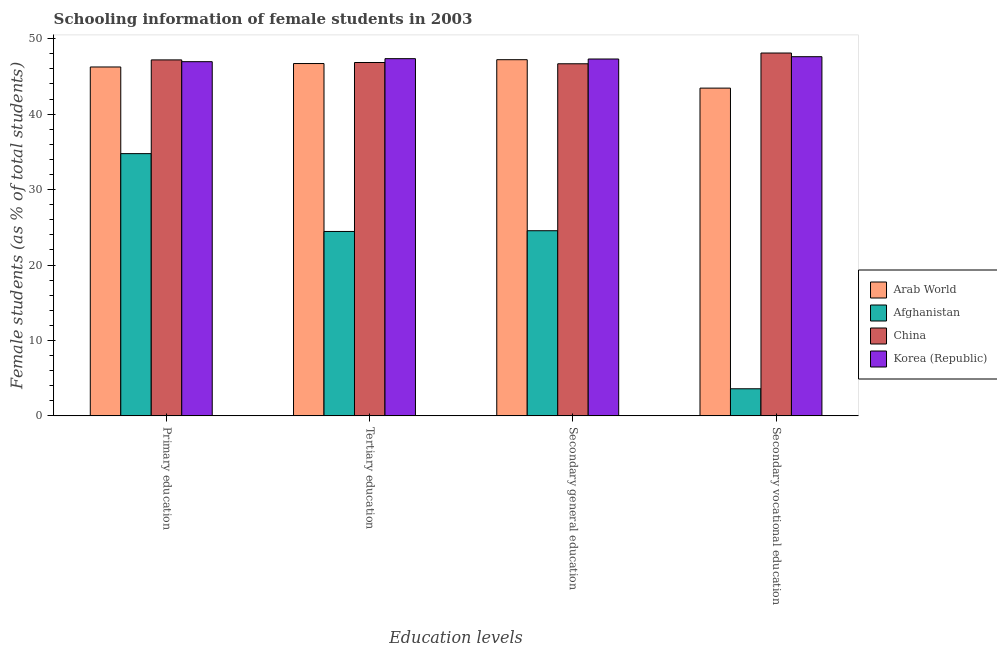Are the number of bars per tick equal to the number of legend labels?
Keep it short and to the point. Yes. Are the number of bars on each tick of the X-axis equal?
Your response must be concise. Yes. What is the label of the 3rd group of bars from the left?
Provide a succinct answer. Secondary general education. What is the percentage of female students in primary education in Afghanistan?
Provide a succinct answer. 34.76. Across all countries, what is the maximum percentage of female students in primary education?
Provide a succinct answer. 47.19. Across all countries, what is the minimum percentage of female students in secondary education?
Provide a short and direct response. 24.54. In which country was the percentage of female students in secondary vocational education maximum?
Your answer should be compact. China. In which country was the percentage of female students in primary education minimum?
Offer a terse response. Afghanistan. What is the total percentage of female students in secondary education in the graph?
Give a very brief answer. 165.75. What is the difference between the percentage of female students in secondary vocational education in Arab World and that in Afghanistan?
Provide a succinct answer. 39.86. What is the difference between the percentage of female students in secondary education in Afghanistan and the percentage of female students in secondary vocational education in China?
Make the answer very short. -23.56. What is the average percentage of female students in primary education per country?
Keep it short and to the point. 43.79. What is the difference between the percentage of female students in secondary vocational education and percentage of female students in secondary education in Arab World?
Provide a succinct answer. -3.77. In how many countries, is the percentage of female students in secondary education greater than 44 %?
Give a very brief answer. 3. What is the ratio of the percentage of female students in tertiary education in Afghanistan to that in Arab World?
Provide a succinct answer. 0.52. What is the difference between the highest and the second highest percentage of female students in secondary education?
Provide a succinct answer. 0.09. What is the difference between the highest and the lowest percentage of female students in tertiary education?
Provide a short and direct response. 22.91. In how many countries, is the percentage of female students in primary education greater than the average percentage of female students in primary education taken over all countries?
Your answer should be very brief. 3. Is the sum of the percentage of female students in tertiary education in China and Korea (Republic) greater than the maximum percentage of female students in primary education across all countries?
Ensure brevity in your answer.  Yes. Is it the case that in every country, the sum of the percentage of female students in secondary vocational education and percentage of female students in tertiary education is greater than the sum of percentage of female students in secondary education and percentage of female students in primary education?
Keep it short and to the point. No. What does the 2nd bar from the left in Secondary general education represents?
Give a very brief answer. Afghanistan. What does the 3rd bar from the right in Secondary general education represents?
Provide a short and direct response. Afghanistan. How many countries are there in the graph?
Offer a very short reply. 4. Are the values on the major ticks of Y-axis written in scientific E-notation?
Offer a terse response. No. Where does the legend appear in the graph?
Your answer should be compact. Center right. How many legend labels are there?
Give a very brief answer. 4. How are the legend labels stacked?
Your answer should be compact. Vertical. What is the title of the graph?
Provide a succinct answer. Schooling information of female students in 2003. Does "Solomon Islands" appear as one of the legend labels in the graph?
Offer a terse response. No. What is the label or title of the X-axis?
Ensure brevity in your answer.  Education levels. What is the label or title of the Y-axis?
Provide a succinct answer. Female students (as % of total students). What is the Female students (as % of total students) in Arab World in Primary education?
Provide a succinct answer. 46.25. What is the Female students (as % of total students) in Afghanistan in Primary education?
Ensure brevity in your answer.  34.76. What is the Female students (as % of total students) of China in Primary education?
Your answer should be very brief. 47.19. What is the Female students (as % of total students) in Korea (Republic) in Primary education?
Your answer should be compact. 46.95. What is the Female students (as % of total students) of Arab World in Tertiary education?
Your answer should be very brief. 46.71. What is the Female students (as % of total students) in Afghanistan in Tertiary education?
Your answer should be very brief. 24.45. What is the Female students (as % of total students) of China in Tertiary education?
Your answer should be compact. 46.85. What is the Female students (as % of total students) in Korea (Republic) in Tertiary education?
Your answer should be compact. 47.35. What is the Female students (as % of total students) of Arab World in Secondary general education?
Keep it short and to the point. 47.22. What is the Female students (as % of total students) of Afghanistan in Secondary general education?
Offer a terse response. 24.54. What is the Female students (as % of total students) in China in Secondary general education?
Offer a terse response. 46.68. What is the Female students (as % of total students) in Korea (Republic) in Secondary general education?
Offer a very short reply. 47.31. What is the Female students (as % of total students) in Arab World in Secondary vocational education?
Give a very brief answer. 43.45. What is the Female students (as % of total students) in Afghanistan in Secondary vocational education?
Offer a terse response. 3.59. What is the Female students (as % of total students) of China in Secondary vocational education?
Your answer should be very brief. 48.1. What is the Female students (as % of total students) in Korea (Republic) in Secondary vocational education?
Make the answer very short. 47.62. Across all Education levels, what is the maximum Female students (as % of total students) in Arab World?
Provide a short and direct response. 47.22. Across all Education levels, what is the maximum Female students (as % of total students) in Afghanistan?
Your answer should be compact. 34.76. Across all Education levels, what is the maximum Female students (as % of total students) of China?
Your response must be concise. 48.1. Across all Education levels, what is the maximum Female students (as % of total students) in Korea (Republic)?
Ensure brevity in your answer.  47.62. Across all Education levels, what is the minimum Female students (as % of total students) of Arab World?
Provide a short and direct response. 43.45. Across all Education levels, what is the minimum Female students (as % of total students) in Afghanistan?
Provide a short and direct response. 3.59. Across all Education levels, what is the minimum Female students (as % of total students) of China?
Provide a succinct answer. 46.68. Across all Education levels, what is the minimum Female students (as % of total students) in Korea (Republic)?
Offer a terse response. 46.95. What is the total Female students (as % of total students) in Arab World in the graph?
Offer a terse response. 183.63. What is the total Female students (as % of total students) of Afghanistan in the graph?
Keep it short and to the point. 87.35. What is the total Female students (as % of total students) in China in the graph?
Give a very brief answer. 188.82. What is the total Female students (as % of total students) in Korea (Republic) in the graph?
Keep it short and to the point. 189.23. What is the difference between the Female students (as % of total students) in Arab World in Primary education and that in Tertiary education?
Provide a succinct answer. -0.46. What is the difference between the Female students (as % of total students) of Afghanistan in Primary education and that in Tertiary education?
Offer a very short reply. 10.32. What is the difference between the Female students (as % of total students) in China in Primary education and that in Tertiary education?
Ensure brevity in your answer.  0.35. What is the difference between the Female students (as % of total students) in Korea (Republic) in Primary education and that in Tertiary education?
Make the answer very short. -0.4. What is the difference between the Female students (as % of total students) of Arab World in Primary education and that in Secondary general education?
Your answer should be compact. -0.96. What is the difference between the Female students (as % of total students) of Afghanistan in Primary education and that in Secondary general education?
Keep it short and to the point. 10.22. What is the difference between the Female students (as % of total students) of China in Primary education and that in Secondary general education?
Offer a terse response. 0.51. What is the difference between the Female students (as % of total students) in Korea (Republic) in Primary education and that in Secondary general education?
Give a very brief answer. -0.35. What is the difference between the Female students (as % of total students) in Arab World in Primary education and that in Secondary vocational education?
Provide a succinct answer. 2.8. What is the difference between the Female students (as % of total students) of Afghanistan in Primary education and that in Secondary vocational education?
Provide a succinct answer. 31.17. What is the difference between the Female students (as % of total students) of China in Primary education and that in Secondary vocational education?
Ensure brevity in your answer.  -0.91. What is the difference between the Female students (as % of total students) of Korea (Republic) in Primary education and that in Secondary vocational education?
Ensure brevity in your answer.  -0.66. What is the difference between the Female students (as % of total students) of Arab World in Tertiary education and that in Secondary general education?
Your answer should be very brief. -0.51. What is the difference between the Female students (as % of total students) in Afghanistan in Tertiary education and that in Secondary general education?
Your answer should be compact. -0.1. What is the difference between the Female students (as % of total students) of China in Tertiary education and that in Secondary general education?
Make the answer very short. 0.17. What is the difference between the Female students (as % of total students) in Korea (Republic) in Tertiary education and that in Secondary general education?
Your answer should be very brief. 0.05. What is the difference between the Female students (as % of total students) in Arab World in Tertiary education and that in Secondary vocational education?
Make the answer very short. 3.26. What is the difference between the Female students (as % of total students) in Afghanistan in Tertiary education and that in Secondary vocational education?
Your answer should be very brief. 20.85. What is the difference between the Female students (as % of total students) in China in Tertiary education and that in Secondary vocational education?
Your answer should be very brief. -1.26. What is the difference between the Female students (as % of total students) in Korea (Republic) in Tertiary education and that in Secondary vocational education?
Your answer should be very brief. -0.26. What is the difference between the Female students (as % of total students) of Arab World in Secondary general education and that in Secondary vocational education?
Your answer should be very brief. 3.77. What is the difference between the Female students (as % of total students) in Afghanistan in Secondary general education and that in Secondary vocational education?
Provide a short and direct response. 20.95. What is the difference between the Female students (as % of total students) in China in Secondary general education and that in Secondary vocational education?
Offer a terse response. -1.43. What is the difference between the Female students (as % of total students) of Korea (Republic) in Secondary general education and that in Secondary vocational education?
Your answer should be compact. -0.31. What is the difference between the Female students (as % of total students) in Arab World in Primary education and the Female students (as % of total students) in Afghanistan in Tertiary education?
Offer a very short reply. 21.81. What is the difference between the Female students (as % of total students) in Arab World in Primary education and the Female students (as % of total students) in China in Tertiary education?
Offer a terse response. -0.59. What is the difference between the Female students (as % of total students) in Arab World in Primary education and the Female students (as % of total students) in Korea (Republic) in Tertiary education?
Give a very brief answer. -1.1. What is the difference between the Female students (as % of total students) in Afghanistan in Primary education and the Female students (as % of total students) in China in Tertiary education?
Ensure brevity in your answer.  -12.08. What is the difference between the Female students (as % of total students) in Afghanistan in Primary education and the Female students (as % of total students) in Korea (Republic) in Tertiary education?
Ensure brevity in your answer.  -12.59. What is the difference between the Female students (as % of total students) of China in Primary education and the Female students (as % of total students) of Korea (Republic) in Tertiary education?
Give a very brief answer. -0.16. What is the difference between the Female students (as % of total students) in Arab World in Primary education and the Female students (as % of total students) in Afghanistan in Secondary general education?
Provide a succinct answer. 21.71. What is the difference between the Female students (as % of total students) in Arab World in Primary education and the Female students (as % of total students) in China in Secondary general education?
Offer a terse response. -0.42. What is the difference between the Female students (as % of total students) of Arab World in Primary education and the Female students (as % of total students) of Korea (Republic) in Secondary general education?
Offer a very short reply. -1.06. What is the difference between the Female students (as % of total students) in Afghanistan in Primary education and the Female students (as % of total students) in China in Secondary general education?
Your answer should be compact. -11.91. What is the difference between the Female students (as % of total students) in Afghanistan in Primary education and the Female students (as % of total students) in Korea (Republic) in Secondary general education?
Ensure brevity in your answer.  -12.54. What is the difference between the Female students (as % of total students) of China in Primary education and the Female students (as % of total students) of Korea (Republic) in Secondary general education?
Keep it short and to the point. -0.12. What is the difference between the Female students (as % of total students) of Arab World in Primary education and the Female students (as % of total students) of Afghanistan in Secondary vocational education?
Keep it short and to the point. 42.66. What is the difference between the Female students (as % of total students) in Arab World in Primary education and the Female students (as % of total students) in China in Secondary vocational education?
Provide a short and direct response. -1.85. What is the difference between the Female students (as % of total students) of Arab World in Primary education and the Female students (as % of total students) of Korea (Republic) in Secondary vocational education?
Provide a succinct answer. -1.36. What is the difference between the Female students (as % of total students) in Afghanistan in Primary education and the Female students (as % of total students) in China in Secondary vocational education?
Your response must be concise. -13.34. What is the difference between the Female students (as % of total students) of Afghanistan in Primary education and the Female students (as % of total students) of Korea (Republic) in Secondary vocational education?
Make the answer very short. -12.85. What is the difference between the Female students (as % of total students) in China in Primary education and the Female students (as % of total students) in Korea (Republic) in Secondary vocational education?
Your answer should be very brief. -0.42. What is the difference between the Female students (as % of total students) in Arab World in Tertiary education and the Female students (as % of total students) in Afghanistan in Secondary general education?
Your answer should be very brief. 22.16. What is the difference between the Female students (as % of total students) in Arab World in Tertiary education and the Female students (as % of total students) in China in Secondary general education?
Offer a terse response. 0.03. What is the difference between the Female students (as % of total students) of Arab World in Tertiary education and the Female students (as % of total students) of Korea (Republic) in Secondary general education?
Provide a succinct answer. -0.6. What is the difference between the Female students (as % of total students) of Afghanistan in Tertiary education and the Female students (as % of total students) of China in Secondary general education?
Offer a terse response. -22.23. What is the difference between the Female students (as % of total students) in Afghanistan in Tertiary education and the Female students (as % of total students) in Korea (Republic) in Secondary general education?
Offer a terse response. -22.86. What is the difference between the Female students (as % of total students) in China in Tertiary education and the Female students (as % of total students) in Korea (Republic) in Secondary general education?
Make the answer very short. -0.46. What is the difference between the Female students (as % of total students) in Arab World in Tertiary education and the Female students (as % of total students) in Afghanistan in Secondary vocational education?
Give a very brief answer. 43.12. What is the difference between the Female students (as % of total students) in Arab World in Tertiary education and the Female students (as % of total students) in China in Secondary vocational education?
Ensure brevity in your answer.  -1.39. What is the difference between the Female students (as % of total students) of Arab World in Tertiary education and the Female students (as % of total students) of Korea (Republic) in Secondary vocational education?
Your response must be concise. -0.91. What is the difference between the Female students (as % of total students) of Afghanistan in Tertiary education and the Female students (as % of total students) of China in Secondary vocational education?
Your answer should be very brief. -23.66. What is the difference between the Female students (as % of total students) of Afghanistan in Tertiary education and the Female students (as % of total students) of Korea (Republic) in Secondary vocational education?
Keep it short and to the point. -23.17. What is the difference between the Female students (as % of total students) of China in Tertiary education and the Female students (as % of total students) of Korea (Republic) in Secondary vocational education?
Keep it short and to the point. -0.77. What is the difference between the Female students (as % of total students) of Arab World in Secondary general education and the Female students (as % of total students) of Afghanistan in Secondary vocational education?
Your answer should be compact. 43.63. What is the difference between the Female students (as % of total students) in Arab World in Secondary general education and the Female students (as % of total students) in China in Secondary vocational education?
Keep it short and to the point. -0.89. What is the difference between the Female students (as % of total students) of Arab World in Secondary general education and the Female students (as % of total students) of Korea (Republic) in Secondary vocational education?
Your response must be concise. -0.4. What is the difference between the Female students (as % of total students) of Afghanistan in Secondary general education and the Female students (as % of total students) of China in Secondary vocational education?
Provide a succinct answer. -23.56. What is the difference between the Female students (as % of total students) in Afghanistan in Secondary general education and the Female students (as % of total students) in Korea (Republic) in Secondary vocational education?
Give a very brief answer. -23.07. What is the difference between the Female students (as % of total students) of China in Secondary general education and the Female students (as % of total students) of Korea (Republic) in Secondary vocational education?
Give a very brief answer. -0.94. What is the average Female students (as % of total students) of Arab World per Education levels?
Make the answer very short. 45.91. What is the average Female students (as % of total students) of Afghanistan per Education levels?
Keep it short and to the point. 21.84. What is the average Female students (as % of total students) in China per Education levels?
Your answer should be compact. 47.2. What is the average Female students (as % of total students) in Korea (Republic) per Education levels?
Your response must be concise. 47.31. What is the difference between the Female students (as % of total students) of Arab World and Female students (as % of total students) of Afghanistan in Primary education?
Give a very brief answer. 11.49. What is the difference between the Female students (as % of total students) in Arab World and Female students (as % of total students) in China in Primary education?
Give a very brief answer. -0.94. What is the difference between the Female students (as % of total students) of Arab World and Female students (as % of total students) of Korea (Republic) in Primary education?
Your response must be concise. -0.7. What is the difference between the Female students (as % of total students) of Afghanistan and Female students (as % of total students) of China in Primary education?
Provide a short and direct response. -12.43. What is the difference between the Female students (as % of total students) of Afghanistan and Female students (as % of total students) of Korea (Republic) in Primary education?
Give a very brief answer. -12.19. What is the difference between the Female students (as % of total students) in China and Female students (as % of total students) in Korea (Republic) in Primary education?
Your answer should be compact. 0.24. What is the difference between the Female students (as % of total students) of Arab World and Female students (as % of total students) of Afghanistan in Tertiary education?
Give a very brief answer. 22.26. What is the difference between the Female students (as % of total students) of Arab World and Female students (as % of total students) of China in Tertiary education?
Offer a very short reply. -0.14. What is the difference between the Female students (as % of total students) in Arab World and Female students (as % of total students) in Korea (Republic) in Tertiary education?
Your response must be concise. -0.65. What is the difference between the Female students (as % of total students) in Afghanistan and Female students (as % of total students) in China in Tertiary education?
Your response must be concise. -22.4. What is the difference between the Female students (as % of total students) in Afghanistan and Female students (as % of total students) in Korea (Republic) in Tertiary education?
Offer a terse response. -22.91. What is the difference between the Female students (as % of total students) in China and Female students (as % of total students) in Korea (Republic) in Tertiary education?
Keep it short and to the point. -0.51. What is the difference between the Female students (as % of total students) in Arab World and Female students (as % of total students) in Afghanistan in Secondary general education?
Keep it short and to the point. 22.67. What is the difference between the Female students (as % of total students) of Arab World and Female students (as % of total students) of China in Secondary general education?
Give a very brief answer. 0.54. What is the difference between the Female students (as % of total students) of Arab World and Female students (as % of total students) of Korea (Republic) in Secondary general education?
Make the answer very short. -0.09. What is the difference between the Female students (as % of total students) in Afghanistan and Female students (as % of total students) in China in Secondary general education?
Offer a very short reply. -22.13. What is the difference between the Female students (as % of total students) of Afghanistan and Female students (as % of total students) of Korea (Republic) in Secondary general education?
Make the answer very short. -22.76. What is the difference between the Female students (as % of total students) of China and Female students (as % of total students) of Korea (Republic) in Secondary general education?
Offer a very short reply. -0.63. What is the difference between the Female students (as % of total students) of Arab World and Female students (as % of total students) of Afghanistan in Secondary vocational education?
Your response must be concise. 39.86. What is the difference between the Female students (as % of total students) in Arab World and Female students (as % of total students) in China in Secondary vocational education?
Provide a succinct answer. -4.65. What is the difference between the Female students (as % of total students) in Arab World and Female students (as % of total students) in Korea (Republic) in Secondary vocational education?
Give a very brief answer. -4.17. What is the difference between the Female students (as % of total students) of Afghanistan and Female students (as % of total students) of China in Secondary vocational education?
Provide a short and direct response. -44.51. What is the difference between the Female students (as % of total students) in Afghanistan and Female students (as % of total students) in Korea (Republic) in Secondary vocational education?
Keep it short and to the point. -44.02. What is the difference between the Female students (as % of total students) in China and Female students (as % of total students) in Korea (Republic) in Secondary vocational education?
Provide a succinct answer. 0.49. What is the ratio of the Female students (as % of total students) of Arab World in Primary education to that in Tertiary education?
Keep it short and to the point. 0.99. What is the ratio of the Female students (as % of total students) in Afghanistan in Primary education to that in Tertiary education?
Your response must be concise. 1.42. What is the ratio of the Female students (as % of total students) in China in Primary education to that in Tertiary education?
Make the answer very short. 1.01. What is the ratio of the Female students (as % of total students) in Korea (Republic) in Primary education to that in Tertiary education?
Offer a terse response. 0.99. What is the ratio of the Female students (as % of total students) of Arab World in Primary education to that in Secondary general education?
Keep it short and to the point. 0.98. What is the ratio of the Female students (as % of total students) in Afghanistan in Primary education to that in Secondary general education?
Offer a terse response. 1.42. What is the ratio of the Female students (as % of total students) of Korea (Republic) in Primary education to that in Secondary general education?
Your response must be concise. 0.99. What is the ratio of the Female students (as % of total students) in Arab World in Primary education to that in Secondary vocational education?
Provide a short and direct response. 1.06. What is the ratio of the Female students (as % of total students) of Afghanistan in Primary education to that in Secondary vocational education?
Ensure brevity in your answer.  9.68. What is the ratio of the Female students (as % of total students) of China in Primary education to that in Secondary vocational education?
Give a very brief answer. 0.98. What is the ratio of the Female students (as % of total students) in Korea (Republic) in Primary education to that in Secondary vocational education?
Offer a very short reply. 0.99. What is the ratio of the Female students (as % of total students) of Afghanistan in Tertiary education to that in Secondary general education?
Your response must be concise. 1. What is the ratio of the Female students (as % of total students) of China in Tertiary education to that in Secondary general education?
Give a very brief answer. 1. What is the ratio of the Female students (as % of total students) in Korea (Republic) in Tertiary education to that in Secondary general education?
Provide a short and direct response. 1. What is the ratio of the Female students (as % of total students) in Arab World in Tertiary education to that in Secondary vocational education?
Offer a very short reply. 1.07. What is the ratio of the Female students (as % of total students) in Afghanistan in Tertiary education to that in Secondary vocational education?
Your answer should be compact. 6.81. What is the ratio of the Female students (as % of total students) in China in Tertiary education to that in Secondary vocational education?
Your response must be concise. 0.97. What is the ratio of the Female students (as % of total students) in Arab World in Secondary general education to that in Secondary vocational education?
Provide a succinct answer. 1.09. What is the ratio of the Female students (as % of total students) of Afghanistan in Secondary general education to that in Secondary vocational education?
Offer a terse response. 6.83. What is the ratio of the Female students (as % of total students) in China in Secondary general education to that in Secondary vocational education?
Give a very brief answer. 0.97. What is the ratio of the Female students (as % of total students) of Korea (Republic) in Secondary general education to that in Secondary vocational education?
Offer a very short reply. 0.99. What is the difference between the highest and the second highest Female students (as % of total students) of Arab World?
Make the answer very short. 0.51. What is the difference between the highest and the second highest Female students (as % of total students) of Afghanistan?
Your response must be concise. 10.22. What is the difference between the highest and the second highest Female students (as % of total students) of China?
Keep it short and to the point. 0.91. What is the difference between the highest and the second highest Female students (as % of total students) of Korea (Republic)?
Your answer should be very brief. 0.26. What is the difference between the highest and the lowest Female students (as % of total students) in Arab World?
Provide a succinct answer. 3.77. What is the difference between the highest and the lowest Female students (as % of total students) in Afghanistan?
Give a very brief answer. 31.17. What is the difference between the highest and the lowest Female students (as % of total students) of China?
Provide a short and direct response. 1.43. What is the difference between the highest and the lowest Female students (as % of total students) in Korea (Republic)?
Offer a very short reply. 0.66. 